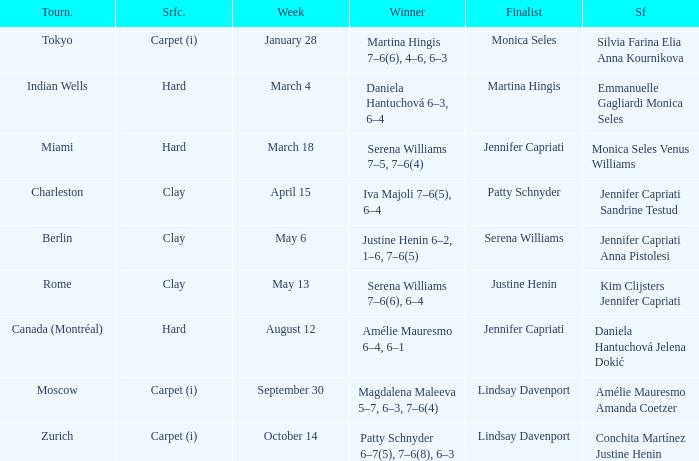What was the surface for finalist Justine Henin? Clay. 